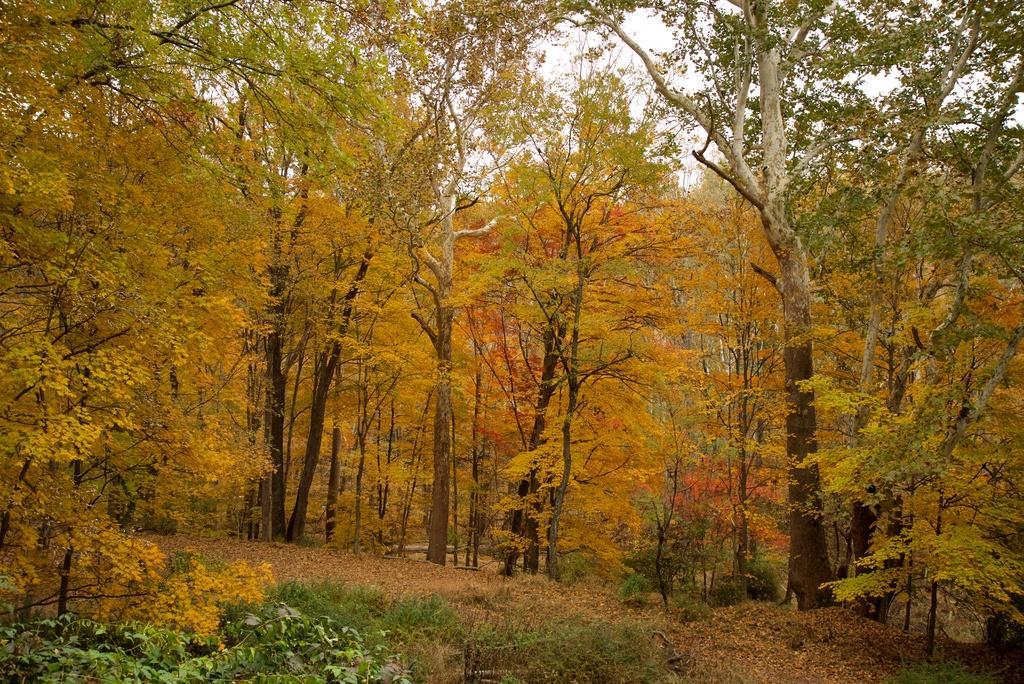Describe this image in one or two sentences. In the center of the image there are trees. At the bottom we can see grass. In the background there is sky. 